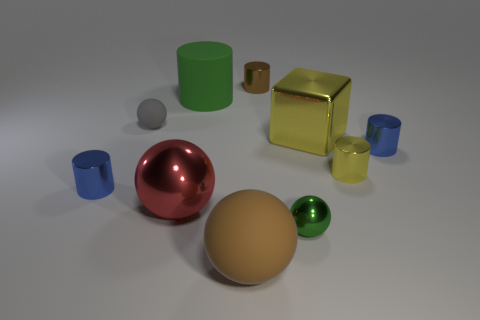Subtract all large rubber cylinders. How many cylinders are left? 4 Subtract 4 balls. How many balls are left? 0 Subtract all brown spheres. How many spheres are left? 3 Subtract all green balls. Subtract all yellow cylinders. How many balls are left? 3 Subtract all red cubes. How many gray spheres are left? 1 Subtract 0 yellow spheres. How many objects are left? 10 Subtract all cubes. How many objects are left? 9 Subtract all large yellow cubes. Subtract all large red metal objects. How many objects are left? 8 Add 1 large brown rubber balls. How many large brown rubber balls are left? 2 Add 3 yellow blocks. How many yellow blocks exist? 4 